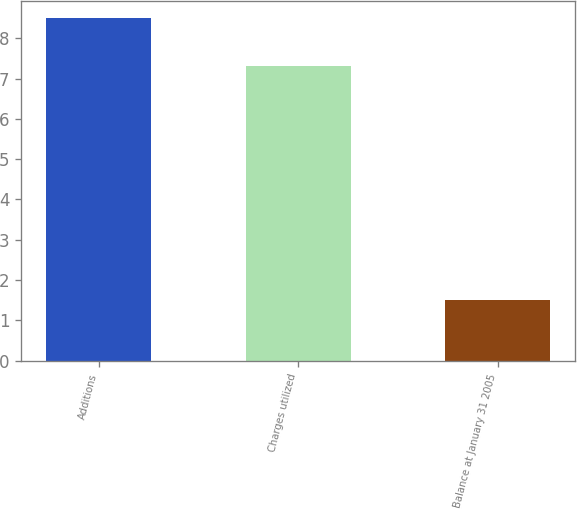<chart> <loc_0><loc_0><loc_500><loc_500><bar_chart><fcel>Additions<fcel>Charges utilized<fcel>Balance at January 31 2005<nl><fcel>8.5<fcel>7.3<fcel>1.5<nl></chart> 